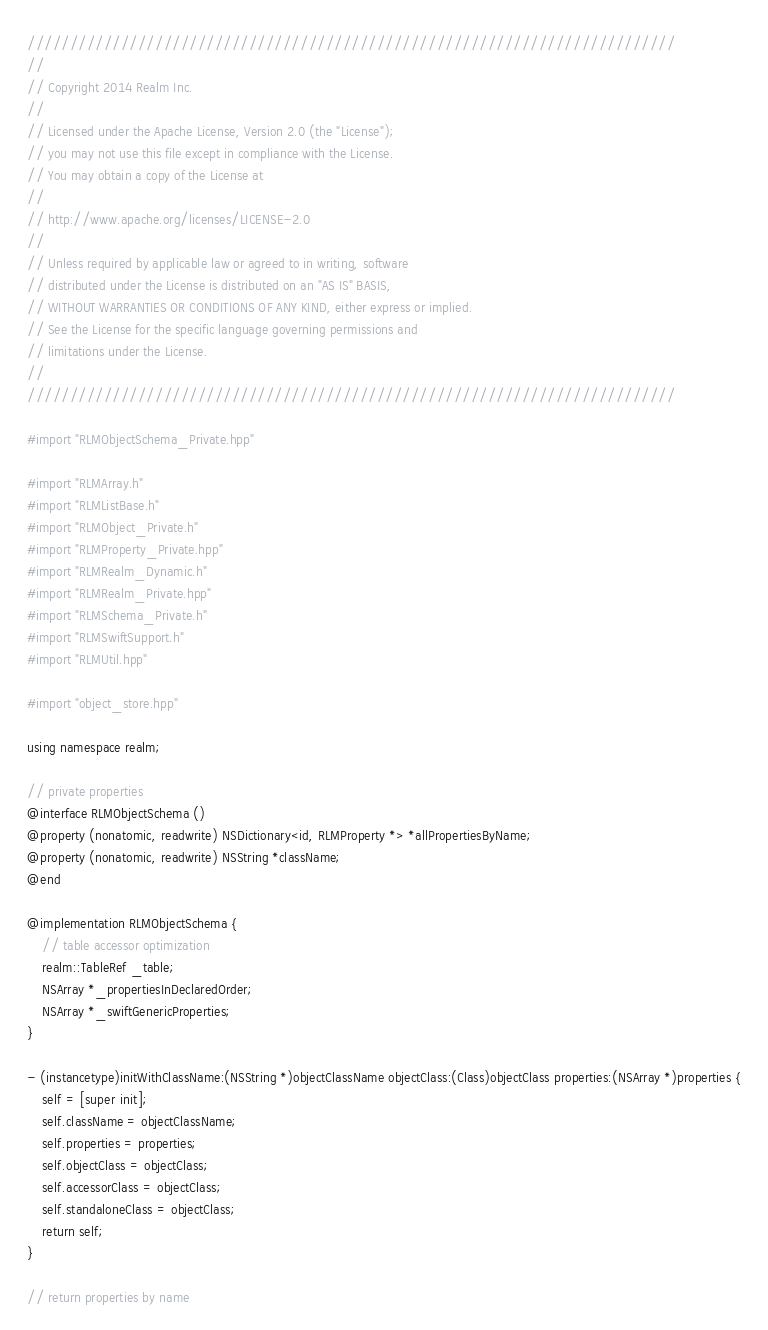<code> <loc_0><loc_0><loc_500><loc_500><_ObjectiveC_>////////////////////////////////////////////////////////////////////////////
//
// Copyright 2014 Realm Inc.
//
// Licensed under the Apache License, Version 2.0 (the "License");
// you may not use this file except in compliance with the License.
// You may obtain a copy of the License at
//
// http://www.apache.org/licenses/LICENSE-2.0
//
// Unless required by applicable law or agreed to in writing, software
// distributed under the License is distributed on an "AS IS" BASIS,
// WITHOUT WARRANTIES OR CONDITIONS OF ANY KIND, either express or implied.
// See the License for the specific language governing permissions and
// limitations under the License.
//
////////////////////////////////////////////////////////////////////////////

#import "RLMObjectSchema_Private.hpp"

#import "RLMArray.h"
#import "RLMListBase.h"
#import "RLMObject_Private.h"
#import "RLMProperty_Private.hpp"
#import "RLMRealm_Dynamic.h"
#import "RLMRealm_Private.hpp"
#import "RLMSchema_Private.h"
#import "RLMSwiftSupport.h"
#import "RLMUtil.hpp"

#import "object_store.hpp"

using namespace realm;

// private properties
@interface RLMObjectSchema ()
@property (nonatomic, readwrite) NSDictionary<id, RLMProperty *> *allPropertiesByName;
@property (nonatomic, readwrite) NSString *className;
@end

@implementation RLMObjectSchema {
    // table accessor optimization
    realm::TableRef _table;
    NSArray *_propertiesInDeclaredOrder;
    NSArray *_swiftGenericProperties;
}

- (instancetype)initWithClassName:(NSString *)objectClassName objectClass:(Class)objectClass properties:(NSArray *)properties {
    self = [super init];
    self.className = objectClassName;
    self.properties = properties;
    self.objectClass = objectClass;
    self.accessorClass = objectClass;
    self.standaloneClass = objectClass;
    return self;
}

// return properties by name</code> 